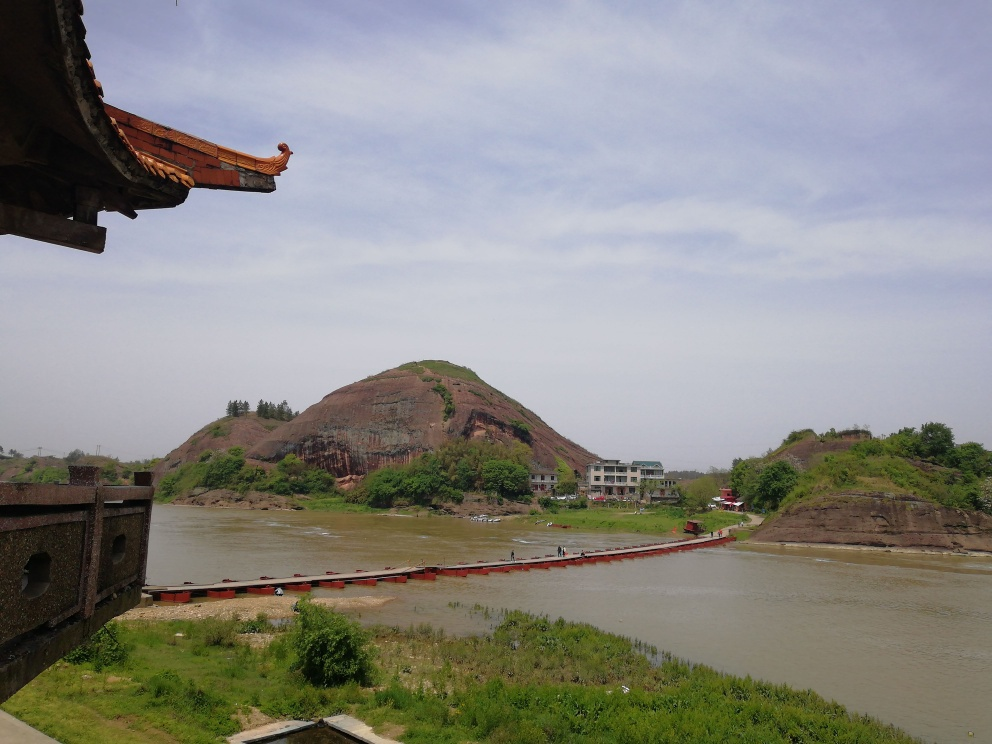What can we infer about the climate of this region? The climate of this region looks temperate, as suggested by the greenery and the level of water in the river. There's no snow or ice, and the vegetation is lush and green, which indicate moderate temperatures and sufficient rainfall to sustain such an ecosystem. 